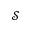Convert formula to latex. <formula><loc_0><loc_0><loc_500><loc_500>\mathcal { S }</formula> 